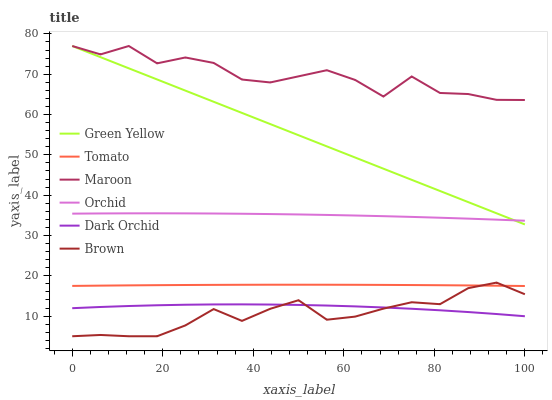Does Brown have the minimum area under the curve?
Answer yes or no. Yes. Does Maroon have the maximum area under the curve?
Answer yes or no. Yes. Does Dark Orchid have the minimum area under the curve?
Answer yes or no. No. Does Dark Orchid have the maximum area under the curve?
Answer yes or no. No. Is Green Yellow the smoothest?
Answer yes or no. Yes. Is Maroon the roughest?
Answer yes or no. Yes. Is Brown the smoothest?
Answer yes or no. No. Is Brown the roughest?
Answer yes or no. No. Does Brown have the lowest value?
Answer yes or no. Yes. Does Dark Orchid have the lowest value?
Answer yes or no. No. Does Green Yellow have the highest value?
Answer yes or no. Yes. Does Brown have the highest value?
Answer yes or no. No. Is Dark Orchid less than Orchid?
Answer yes or no. Yes. Is Tomato greater than Dark Orchid?
Answer yes or no. Yes. Does Orchid intersect Green Yellow?
Answer yes or no. Yes. Is Orchid less than Green Yellow?
Answer yes or no. No. Is Orchid greater than Green Yellow?
Answer yes or no. No. Does Dark Orchid intersect Orchid?
Answer yes or no. No. 